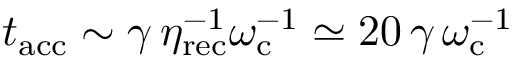<formula> <loc_0><loc_0><loc_500><loc_500>t _ { a c c } \sim \gamma \, \eta _ { r e c } ^ { - 1 } \omega _ { c } ^ { - 1 } \simeq 2 0 \, \gamma \, \omega _ { c } ^ { - 1 }</formula> 